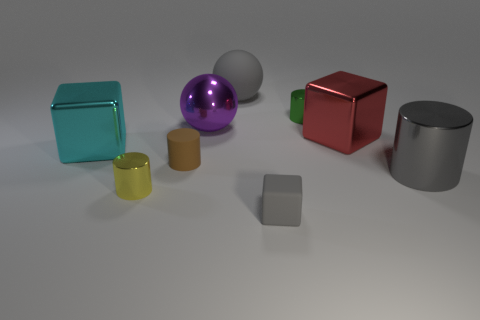Subtract 1 cylinders. How many cylinders are left? 3 Add 1 tiny yellow metallic balls. How many objects exist? 10 Subtract all spheres. How many objects are left? 7 Subtract all cyan shiny things. Subtract all cyan metal cubes. How many objects are left? 7 Add 7 cubes. How many cubes are left? 10 Add 2 large matte things. How many large matte things exist? 3 Subtract 0 blue cylinders. How many objects are left? 9 